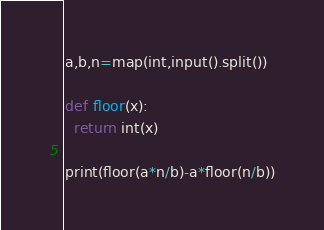<code> <loc_0><loc_0><loc_500><loc_500><_Python_>a,b,n=map(int,input().split())

def floor(x):
  return int(x)

print(floor(a*n/b)-a*floor(n/b))
</code> 